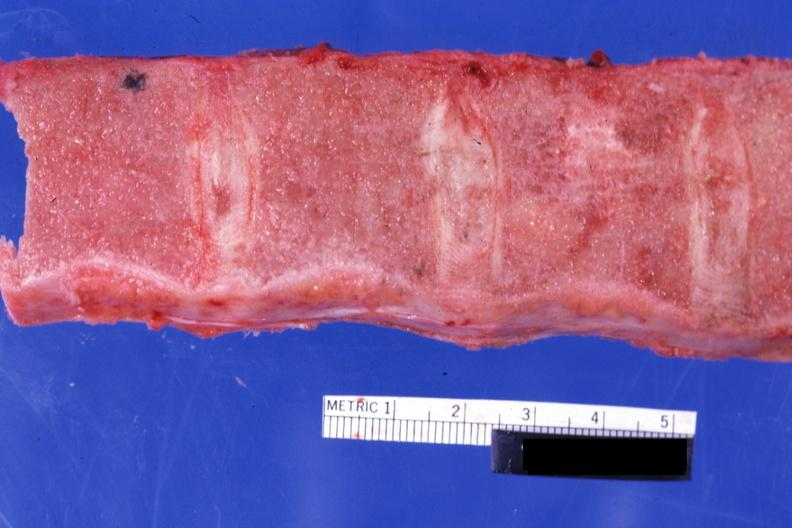s there present?
Answer the question using a single word or phrase. No 